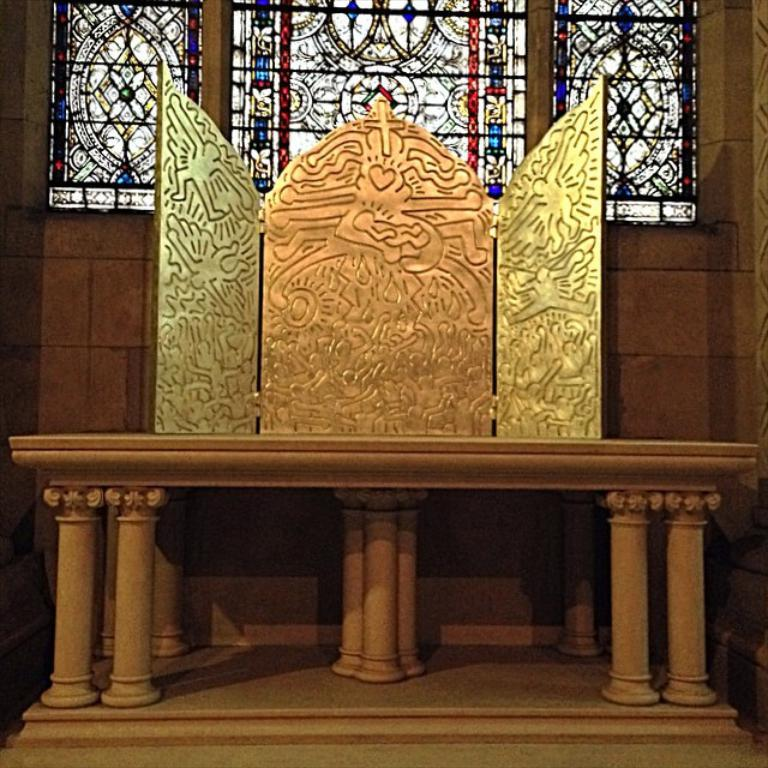What type of table is in the image? There is a marble table in the image. What is placed on the marble table? There is a golden-colored object on the table. Can you describe the appearance of the golden-colored object? The golden-colored object has designs on it. What can be seen in the background of the image? There is a glass window in the background of the image. What type of kitty is providing scientific treatment in the image? There is no kitty or scientific treatment present in the image. 